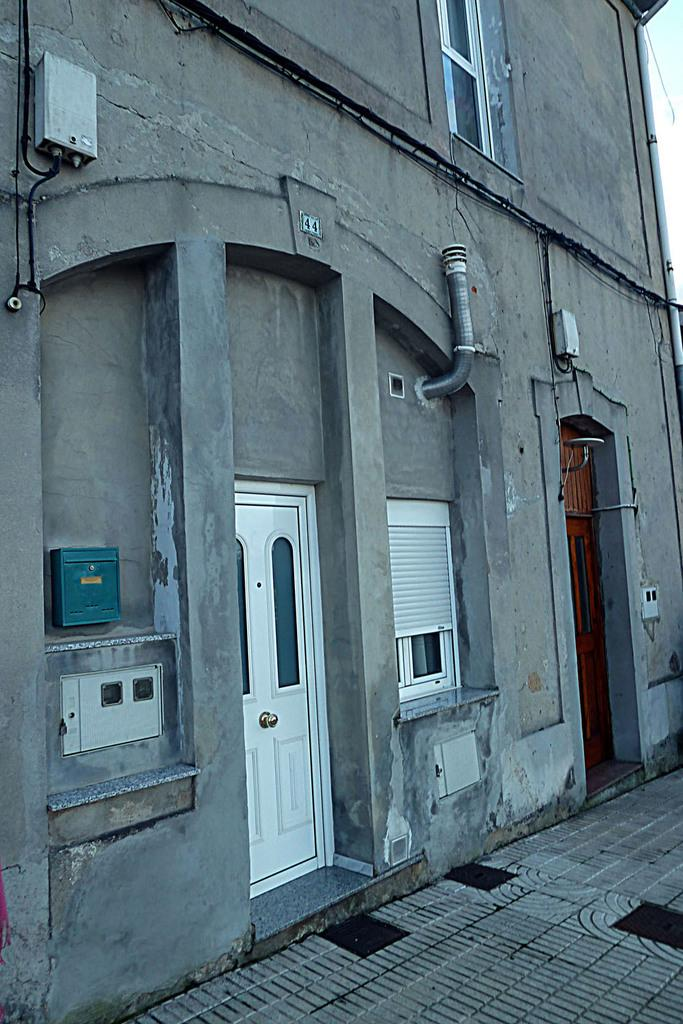What type of structure is present in the image? There is a building in the image. What specific features can be seen on the building? The building has pipes, windows, and a door. What can be seen in the background of the image? The sky is visible in the background of the image. What type of guitar is being played by the duck in the image? There is no guitar or duck present in the image; it features a building with pipes, windows, and a door. Is there any oatmeal visible in the image? There is no oatmeal present in the image. 